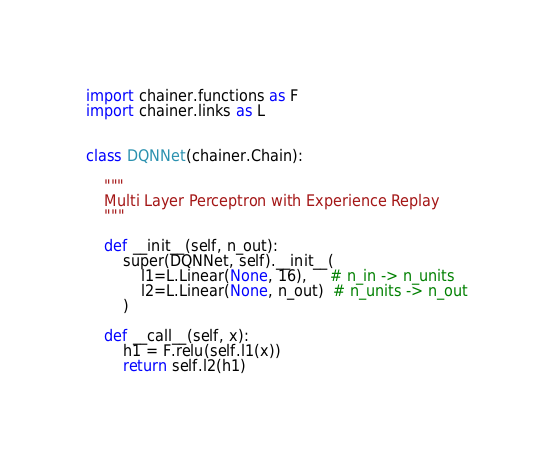<code> <loc_0><loc_0><loc_500><loc_500><_Python_>import chainer.functions as F
import chainer.links as L


class DQNNet(chainer.Chain):

    """
    Multi Layer Perceptron with Experience Replay
    """

    def __init__(self, n_out):
        super(DQNNet, self).__init__(
            l1=L.Linear(None, 16),     # n_in -> n_units
            l2=L.Linear(None, n_out)  # n_units -> n_out
        )

    def __call__(self, x):
        h1 = F.relu(self.l1(x))
        return self.l2(h1)
</code> 